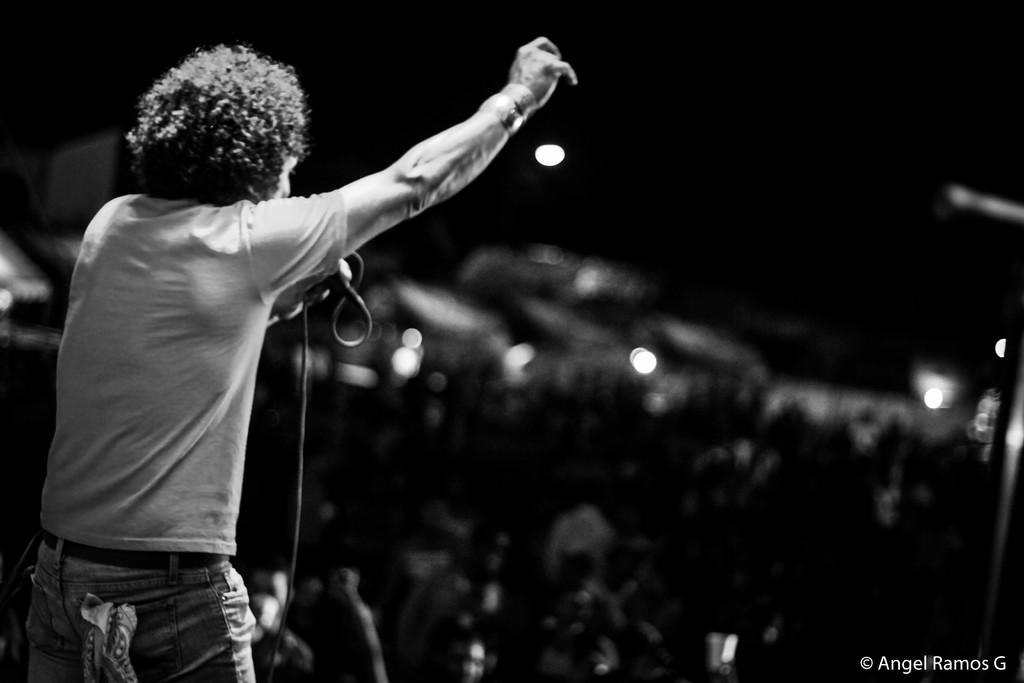Who is the main subject in the image? There is a man in the image. Where is the man located in the image? The man is on the left side of the image. What is the man holding in the image? The man appears to be holding a microphone. What type of clothing is the man wearing on his upper body? The man is wearing a T-shirt. What type of clothing is the man wearing on his lower body? The man is wearing pants. What type of cake is the man cutting in the image? There is no cake present in the image; the man is holding a microphone. What color is the ink on the man's shirt in the image? The man is wearing a T-shirt, but there is no mention of ink or any design on it, so we cannot determine the color of the ink. 